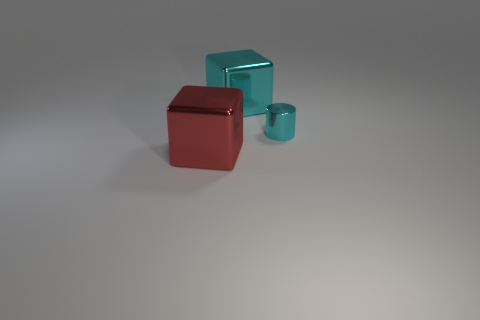How many things are large cyan matte cylinders or metal objects?
Make the answer very short. 3. Do the red metal block and the object that is behind the cyan metallic cylinder have the same size?
Ensure brevity in your answer.  Yes. There is a metallic cube that is behind the small cyan object that is in front of the big block that is right of the big red metal cube; what is its size?
Offer a terse response. Large. Is there a big red metallic block?
Keep it short and to the point. Yes. What is the material of the big thing that is the same color as the small shiny cylinder?
Your answer should be very brief. Metal. What number of other small metal cylinders are the same color as the tiny metal cylinder?
Keep it short and to the point. 0. What number of things are large shiny objects on the right side of the red metallic block or large metallic blocks that are behind the tiny thing?
Ensure brevity in your answer.  1. There is a cyan shiny thing on the left side of the tiny metallic cylinder; how many red objects are behind it?
Provide a succinct answer. 0. What is the color of the tiny cylinder that is the same material as the big cyan object?
Offer a very short reply. Cyan. Are there any things of the same size as the red metal block?
Ensure brevity in your answer.  Yes. 